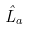<formula> <loc_0><loc_0><loc_500><loc_500>\hat { L } _ { a }</formula> 